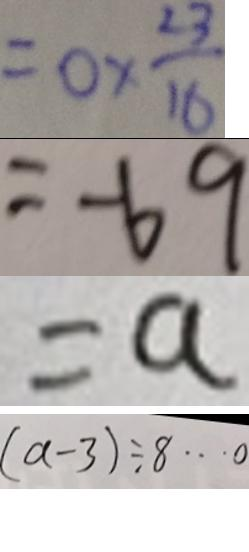Convert formula to latex. <formula><loc_0><loc_0><loc_500><loc_500>= 0 \times \frac { 2 3 } { 1 6 } 
 = - 6 9 
 = a 
 ( a - 3 ) \div 8 \cdots 0</formula> 